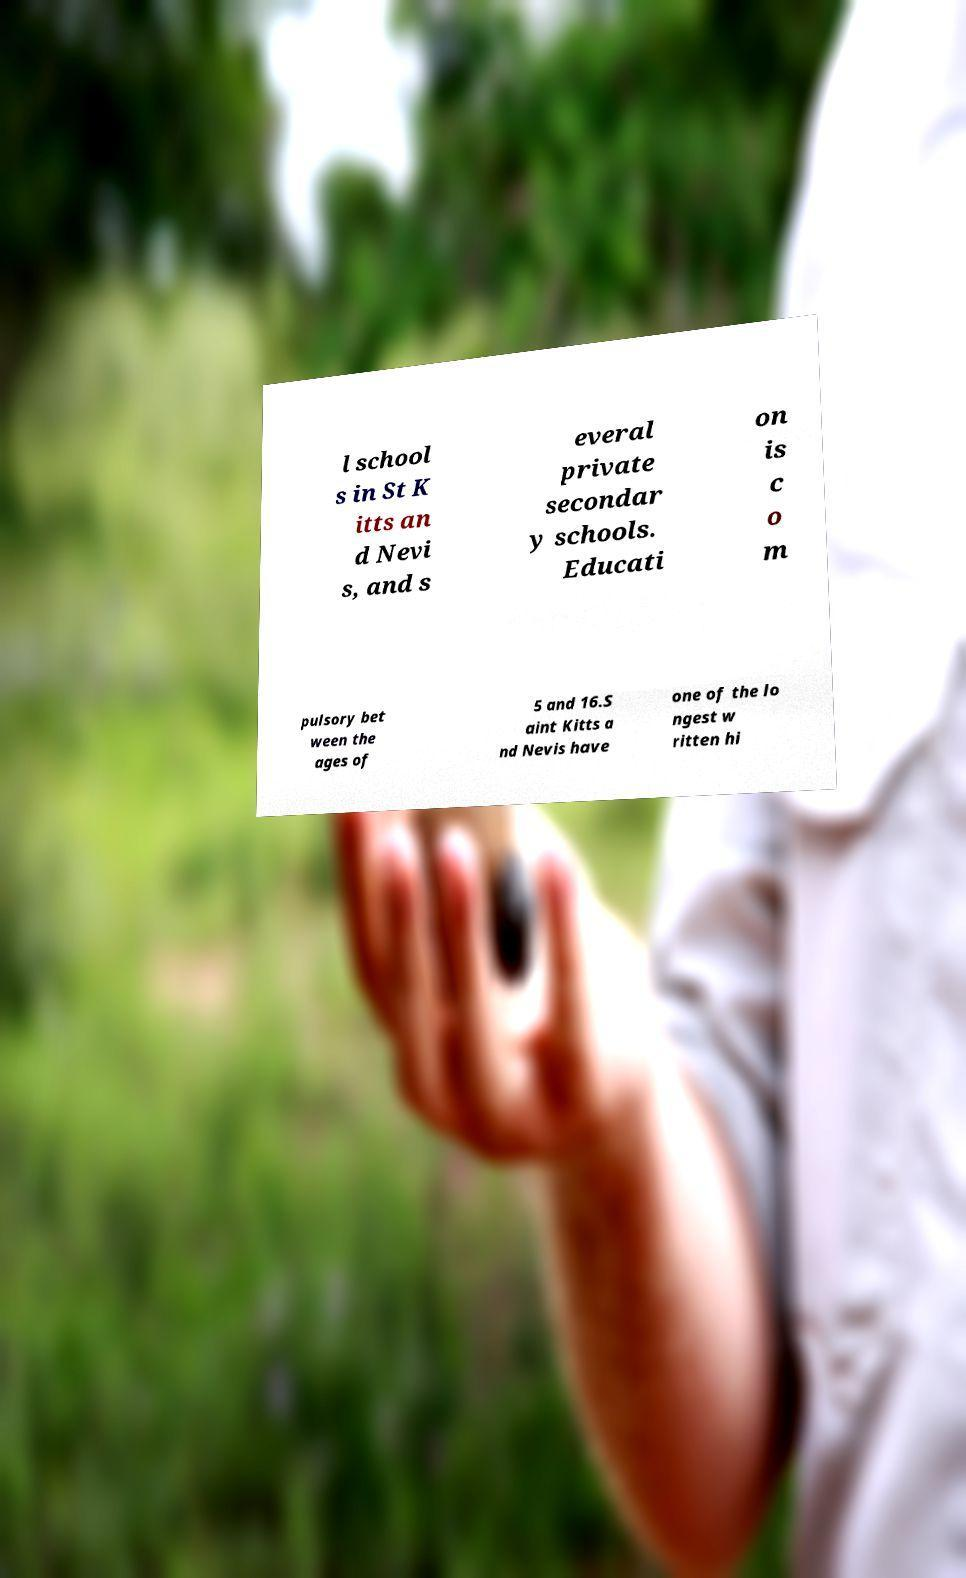Could you extract and type out the text from this image? l school s in St K itts an d Nevi s, and s everal private secondar y schools. Educati on is c o m pulsory bet ween the ages of 5 and 16.S aint Kitts a nd Nevis have one of the lo ngest w ritten hi 